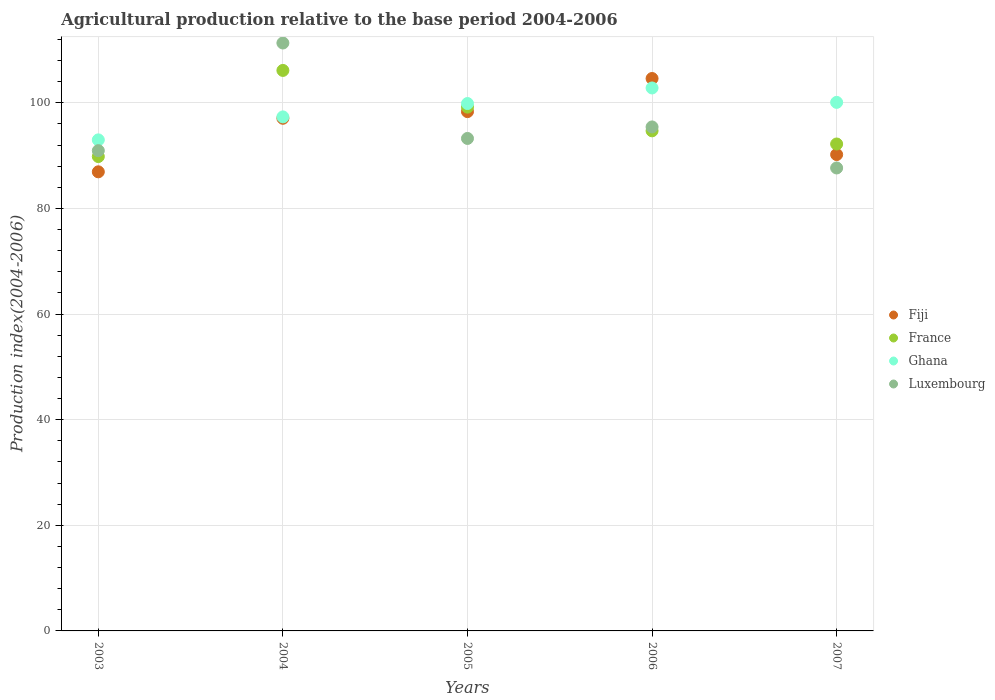How many different coloured dotlines are there?
Provide a succinct answer. 4. Is the number of dotlines equal to the number of legend labels?
Your answer should be very brief. Yes. What is the agricultural production index in Fiji in 2006?
Keep it short and to the point. 104.6. Across all years, what is the maximum agricultural production index in Ghana?
Provide a succinct answer. 102.81. Across all years, what is the minimum agricultural production index in France?
Your response must be concise. 89.82. In which year was the agricultural production index in Fiji maximum?
Ensure brevity in your answer.  2006. What is the total agricultural production index in Ghana in the graph?
Your response must be concise. 493.06. What is the difference between the agricultural production index in France in 2003 and that in 2006?
Ensure brevity in your answer.  -4.87. What is the difference between the agricultural production index in Fiji in 2006 and the agricultural production index in Luxembourg in 2007?
Your answer should be very brief. 16.94. What is the average agricultural production index in Ghana per year?
Make the answer very short. 98.61. In the year 2007, what is the difference between the agricultural production index in Luxembourg and agricultural production index in Ghana?
Make the answer very short. -12.42. What is the ratio of the agricultural production index in Ghana in 2003 to that in 2007?
Your response must be concise. 0.93. Is the agricultural production index in Luxembourg in 2003 less than that in 2005?
Provide a succinct answer. Yes. What is the difference between the highest and the second highest agricultural production index in Fiji?
Provide a succinct answer. 6.27. What is the difference between the highest and the lowest agricultural production index in Luxembourg?
Make the answer very short. 23.66. Is it the case that in every year, the sum of the agricultural production index in Luxembourg and agricultural production index in Ghana  is greater than the agricultural production index in France?
Offer a terse response. Yes. Is the agricultural production index in Luxembourg strictly less than the agricultural production index in Ghana over the years?
Your response must be concise. No. How many years are there in the graph?
Give a very brief answer. 5. What is the difference between two consecutive major ticks on the Y-axis?
Offer a very short reply. 20. Are the values on the major ticks of Y-axis written in scientific E-notation?
Provide a short and direct response. No. How many legend labels are there?
Your answer should be compact. 4. What is the title of the graph?
Make the answer very short. Agricultural production relative to the base period 2004-2006. What is the label or title of the X-axis?
Provide a succinct answer. Years. What is the label or title of the Y-axis?
Give a very brief answer. Production index(2004-2006). What is the Production index(2004-2006) of Fiji in 2003?
Provide a short and direct response. 86.93. What is the Production index(2004-2006) of France in 2003?
Keep it short and to the point. 89.82. What is the Production index(2004-2006) in Ghana in 2003?
Provide a short and direct response. 92.98. What is the Production index(2004-2006) in Luxembourg in 2003?
Ensure brevity in your answer.  90.94. What is the Production index(2004-2006) in Fiji in 2004?
Ensure brevity in your answer.  97.07. What is the Production index(2004-2006) of France in 2004?
Offer a terse response. 106.13. What is the Production index(2004-2006) in Ghana in 2004?
Your answer should be compact. 97.33. What is the Production index(2004-2006) of Luxembourg in 2004?
Give a very brief answer. 111.32. What is the Production index(2004-2006) of Fiji in 2005?
Provide a succinct answer. 98.33. What is the Production index(2004-2006) of France in 2005?
Ensure brevity in your answer.  99.18. What is the Production index(2004-2006) of Ghana in 2005?
Provide a succinct answer. 99.86. What is the Production index(2004-2006) of Luxembourg in 2005?
Your response must be concise. 93.25. What is the Production index(2004-2006) in Fiji in 2006?
Ensure brevity in your answer.  104.6. What is the Production index(2004-2006) of France in 2006?
Ensure brevity in your answer.  94.69. What is the Production index(2004-2006) in Ghana in 2006?
Offer a terse response. 102.81. What is the Production index(2004-2006) in Luxembourg in 2006?
Make the answer very short. 95.43. What is the Production index(2004-2006) in Fiji in 2007?
Your response must be concise. 90.2. What is the Production index(2004-2006) of France in 2007?
Provide a short and direct response. 92.2. What is the Production index(2004-2006) of Ghana in 2007?
Ensure brevity in your answer.  100.08. What is the Production index(2004-2006) of Luxembourg in 2007?
Provide a succinct answer. 87.66. Across all years, what is the maximum Production index(2004-2006) of Fiji?
Provide a short and direct response. 104.6. Across all years, what is the maximum Production index(2004-2006) in France?
Ensure brevity in your answer.  106.13. Across all years, what is the maximum Production index(2004-2006) in Ghana?
Keep it short and to the point. 102.81. Across all years, what is the maximum Production index(2004-2006) in Luxembourg?
Offer a terse response. 111.32. Across all years, what is the minimum Production index(2004-2006) of Fiji?
Offer a very short reply. 86.93. Across all years, what is the minimum Production index(2004-2006) of France?
Give a very brief answer. 89.82. Across all years, what is the minimum Production index(2004-2006) of Ghana?
Your response must be concise. 92.98. Across all years, what is the minimum Production index(2004-2006) of Luxembourg?
Offer a terse response. 87.66. What is the total Production index(2004-2006) of Fiji in the graph?
Give a very brief answer. 477.13. What is the total Production index(2004-2006) of France in the graph?
Keep it short and to the point. 482.02. What is the total Production index(2004-2006) in Ghana in the graph?
Ensure brevity in your answer.  493.06. What is the total Production index(2004-2006) of Luxembourg in the graph?
Your answer should be very brief. 478.6. What is the difference between the Production index(2004-2006) in Fiji in 2003 and that in 2004?
Ensure brevity in your answer.  -10.14. What is the difference between the Production index(2004-2006) in France in 2003 and that in 2004?
Make the answer very short. -16.31. What is the difference between the Production index(2004-2006) in Ghana in 2003 and that in 2004?
Offer a very short reply. -4.35. What is the difference between the Production index(2004-2006) in Luxembourg in 2003 and that in 2004?
Your response must be concise. -20.38. What is the difference between the Production index(2004-2006) in Fiji in 2003 and that in 2005?
Keep it short and to the point. -11.4. What is the difference between the Production index(2004-2006) in France in 2003 and that in 2005?
Keep it short and to the point. -9.36. What is the difference between the Production index(2004-2006) in Ghana in 2003 and that in 2005?
Your answer should be compact. -6.88. What is the difference between the Production index(2004-2006) in Luxembourg in 2003 and that in 2005?
Keep it short and to the point. -2.31. What is the difference between the Production index(2004-2006) of Fiji in 2003 and that in 2006?
Provide a succinct answer. -17.67. What is the difference between the Production index(2004-2006) in France in 2003 and that in 2006?
Your answer should be compact. -4.87. What is the difference between the Production index(2004-2006) in Ghana in 2003 and that in 2006?
Make the answer very short. -9.83. What is the difference between the Production index(2004-2006) in Luxembourg in 2003 and that in 2006?
Keep it short and to the point. -4.49. What is the difference between the Production index(2004-2006) of Fiji in 2003 and that in 2007?
Make the answer very short. -3.27. What is the difference between the Production index(2004-2006) of France in 2003 and that in 2007?
Make the answer very short. -2.38. What is the difference between the Production index(2004-2006) in Luxembourg in 2003 and that in 2007?
Provide a short and direct response. 3.28. What is the difference between the Production index(2004-2006) in Fiji in 2004 and that in 2005?
Provide a short and direct response. -1.26. What is the difference between the Production index(2004-2006) in France in 2004 and that in 2005?
Ensure brevity in your answer.  6.95. What is the difference between the Production index(2004-2006) of Ghana in 2004 and that in 2005?
Your response must be concise. -2.53. What is the difference between the Production index(2004-2006) in Luxembourg in 2004 and that in 2005?
Your response must be concise. 18.07. What is the difference between the Production index(2004-2006) in Fiji in 2004 and that in 2006?
Offer a very short reply. -7.53. What is the difference between the Production index(2004-2006) of France in 2004 and that in 2006?
Keep it short and to the point. 11.44. What is the difference between the Production index(2004-2006) of Ghana in 2004 and that in 2006?
Provide a short and direct response. -5.48. What is the difference between the Production index(2004-2006) in Luxembourg in 2004 and that in 2006?
Your answer should be compact. 15.89. What is the difference between the Production index(2004-2006) of Fiji in 2004 and that in 2007?
Offer a very short reply. 6.87. What is the difference between the Production index(2004-2006) in France in 2004 and that in 2007?
Keep it short and to the point. 13.93. What is the difference between the Production index(2004-2006) in Ghana in 2004 and that in 2007?
Provide a short and direct response. -2.75. What is the difference between the Production index(2004-2006) in Luxembourg in 2004 and that in 2007?
Offer a terse response. 23.66. What is the difference between the Production index(2004-2006) in Fiji in 2005 and that in 2006?
Ensure brevity in your answer.  -6.27. What is the difference between the Production index(2004-2006) in France in 2005 and that in 2006?
Make the answer very short. 4.49. What is the difference between the Production index(2004-2006) in Ghana in 2005 and that in 2006?
Provide a short and direct response. -2.95. What is the difference between the Production index(2004-2006) in Luxembourg in 2005 and that in 2006?
Provide a short and direct response. -2.18. What is the difference between the Production index(2004-2006) of Fiji in 2005 and that in 2007?
Make the answer very short. 8.13. What is the difference between the Production index(2004-2006) of France in 2005 and that in 2007?
Offer a terse response. 6.98. What is the difference between the Production index(2004-2006) in Ghana in 2005 and that in 2007?
Make the answer very short. -0.22. What is the difference between the Production index(2004-2006) in Luxembourg in 2005 and that in 2007?
Your answer should be very brief. 5.59. What is the difference between the Production index(2004-2006) in Fiji in 2006 and that in 2007?
Make the answer very short. 14.4. What is the difference between the Production index(2004-2006) of France in 2006 and that in 2007?
Make the answer very short. 2.49. What is the difference between the Production index(2004-2006) in Ghana in 2006 and that in 2007?
Provide a short and direct response. 2.73. What is the difference between the Production index(2004-2006) of Luxembourg in 2006 and that in 2007?
Ensure brevity in your answer.  7.77. What is the difference between the Production index(2004-2006) in Fiji in 2003 and the Production index(2004-2006) in France in 2004?
Offer a very short reply. -19.2. What is the difference between the Production index(2004-2006) in Fiji in 2003 and the Production index(2004-2006) in Luxembourg in 2004?
Provide a succinct answer. -24.39. What is the difference between the Production index(2004-2006) of France in 2003 and the Production index(2004-2006) of Ghana in 2004?
Ensure brevity in your answer.  -7.51. What is the difference between the Production index(2004-2006) of France in 2003 and the Production index(2004-2006) of Luxembourg in 2004?
Keep it short and to the point. -21.5. What is the difference between the Production index(2004-2006) of Ghana in 2003 and the Production index(2004-2006) of Luxembourg in 2004?
Offer a terse response. -18.34. What is the difference between the Production index(2004-2006) of Fiji in 2003 and the Production index(2004-2006) of France in 2005?
Offer a terse response. -12.25. What is the difference between the Production index(2004-2006) of Fiji in 2003 and the Production index(2004-2006) of Ghana in 2005?
Ensure brevity in your answer.  -12.93. What is the difference between the Production index(2004-2006) of Fiji in 2003 and the Production index(2004-2006) of Luxembourg in 2005?
Offer a terse response. -6.32. What is the difference between the Production index(2004-2006) in France in 2003 and the Production index(2004-2006) in Ghana in 2005?
Offer a very short reply. -10.04. What is the difference between the Production index(2004-2006) of France in 2003 and the Production index(2004-2006) of Luxembourg in 2005?
Provide a succinct answer. -3.43. What is the difference between the Production index(2004-2006) of Ghana in 2003 and the Production index(2004-2006) of Luxembourg in 2005?
Your response must be concise. -0.27. What is the difference between the Production index(2004-2006) of Fiji in 2003 and the Production index(2004-2006) of France in 2006?
Your answer should be compact. -7.76. What is the difference between the Production index(2004-2006) of Fiji in 2003 and the Production index(2004-2006) of Ghana in 2006?
Offer a very short reply. -15.88. What is the difference between the Production index(2004-2006) in Fiji in 2003 and the Production index(2004-2006) in Luxembourg in 2006?
Offer a very short reply. -8.5. What is the difference between the Production index(2004-2006) in France in 2003 and the Production index(2004-2006) in Ghana in 2006?
Offer a very short reply. -12.99. What is the difference between the Production index(2004-2006) in France in 2003 and the Production index(2004-2006) in Luxembourg in 2006?
Keep it short and to the point. -5.61. What is the difference between the Production index(2004-2006) of Ghana in 2003 and the Production index(2004-2006) of Luxembourg in 2006?
Your answer should be compact. -2.45. What is the difference between the Production index(2004-2006) in Fiji in 2003 and the Production index(2004-2006) in France in 2007?
Ensure brevity in your answer.  -5.27. What is the difference between the Production index(2004-2006) of Fiji in 2003 and the Production index(2004-2006) of Ghana in 2007?
Make the answer very short. -13.15. What is the difference between the Production index(2004-2006) in Fiji in 2003 and the Production index(2004-2006) in Luxembourg in 2007?
Keep it short and to the point. -0.73. What is the difference between the Production index(2004-2006) of France in 2003 and the Production index(2004-2006) of Ghana in 2007?
Your answer should be compact. -10.26. What is the difference between the Production index(2004-2006) in France in 2003 and the Production index(2004-2006) in Luxembourg in 2007?
Provide a short and direct response. 2.16. What is the difference between the Production index(2004-2006) in Ghana in 2003 and the Production index(2004-2006) in Luxembourg in 2007?
Your response must be concise. 5.32. What is the difference between the Production index(2004-2006) in Fiji in 2004 and the Production index(2004-2006) in France in 2005?
Keep it short and to the point. -2.11. What is the difference between the Production index(2004-2006) of Fiji in 2004 and the Production index(2004-2006) of Ghana in 2005?
Give a very brief answer. -2.79. What is the difference between the Production index(2004-2006) of Fiji in 2004 and the Production index(2004-2006) of Luxembourg in 2005?
Make the answer very short. 3.82. What is the difference between the Production index(2004-2006) of France in 2004 and the Production index(2004-2006) of Ghana in 2005?
Give a very brief answer. 6.27. What is the difference between the Production index(2004-2006) in France in 2004 and the Production index(2004-2006) in Luxembourg in 2005?
Your answer should be very brief. 12.88. What is the difference between the Production index(2004-2006) in Ghana in 2004 and the Production index(2004-2006) in Luxembourg in 2005?
Your response must be concise. 4.08. What is the difference between the Production index(2004-2006) in Fiji in 2004 and the Production index(2004-2006) in France in 2006?
Offer a terse response. 2.38. What is the difference between the Production index(2004-2006) in Fiji in 2004 and the Production index(2004-2006) in Ghana in 2006?
Ensure brevity in your answer.  -5.74. What is the difference between the Production index(2004-2006) in Fiji in 2004 and the Production index(2004-2006) in Luxembourg in 2006?
Your answer should be compact. 1.64. What is the difference between the Production index(2004-2006) in France in 2004 and the Production index(2004-2006) in Ghana in 2006?
Give a very brief answer. 3.32. What is the difference between the Production index(2004-2006) in Ghana in 2004 and the Production index(2004-2006) in Luxembourg in 2006?
Your answer should be very brief. 1.9. What is the difference between the Production index(2004-2006) in Fiji in 2004 and the Production index(2004-2006) in France in 2007?
Your answer should be compact. 4.87. What is the difference between the Production index(2004-2006) of Fiji in 2004 and the Production index(2004-2006) of Ghana in 2007?
Your answer should be compact. -3.01. What is the difference between the Production index(2004-2006) in Fiji in 2004 and the Production index(2004-2006) in Luxembourg in 2007?
Offer a terse response. 9.41. What is the difference between the Production index(2004-2006) in France in 2004 and the Production index(2004-2006) in Ghana in 2007?
Provide a succinct answer. 6.05. What is the difference between the Production index(2004-2006) of France in 2004 and the Production index(2004-2006) of Luxembourg in 2007?
Keep it short and to the point. 18.47. What is the difference between the Production index(2004-2006) in Ghana in 2004 and the Production index(2004-2006) in Luxembourg in 2007?
Your answer should be very brief. 9.67. What is the difference between the Production index(2004-2006) of Fiji in 2005 and the Production index(2004-2006) of France in 2006?
Offer a very short reply. 3.64. What is the difference between the Production index(2004-2006) in Fiji in 2005 and the Production index(2004-2006) in Ghana in 2006?
Provide a short and direct response. -4.48. What is the difference between the Production index(2004-2006) in Fiji in 2005 and the Production index(2004-2006) in Luxembourg in 2006?
Offer a very short reply. 2.9. What is the difference between the Production index(2004-2006) in France in 2005 and the Production index(2004-2006) in Ghana in 2006?
Your answer should be compact. -3.63. What is the difference between the Production index(2004-2006) in France in 2005 and the Production index(2004-2006) in Luxembourg in 2006?
Your answer should be very brief. 3.75. What is the difference between the Production index(2004-2006) of Ghana in 2005 and the Production index(2004-2006) of Luxembourg in 2006?
Ensure brevity in your answer.  4.43. What is the difference between the Production index(2004-2006) of Fiji in 2005 and the Production index(2004-2006) of France in 2007?
Provide a succinct answer. 6.13. What is the difference between the Production index(2004-2006) of Fiji in 2005 and the Production index(2004-2006) of Ghana in 2007?
Provide a short and direct response. -1.75. What is the difference between the Production index(2004-2006) of Fiji in 2005 and the Production index(2004-2006) of Luxembourg in 2007?
Your answer should be very brief. 10.67. What is the difference between the Production index(2004-2006) in France in 2005 and the Production index(2004-2006) in Ghana in 2007?
Make the answer very short. -0.9. What is the difference between the Production index(2004-2006) of France in 2005 and the Production index(2004-2006) of Luxembourg in 2007?
Provide a succinct answer. 11.52. What is the difference between the Production index(2004-2006) of Ghana in 2005 and the Production index(2004-2006) of Luxembourg in 2007?
Offer a very short reply. 12.2. What is the difference between the Production index(2004-2006) in Fiji in 2006 and the Production index(2004-2006) in France in 2007?
Provide a succinct answer. 12.4. What is the difference between the Production index(2004-2006) of Fiji in 2006 and the Production index(2004-2006) of Ghana in 2007?
Keep it short and to the point. 4.52. What is the difference between the Production index(2004-2006) in Fiji in 2006 and the Production index(2004-2006) in Luxembourg in 2007?
Offer a very short reply. 16.94. What is the difference between the Production index(2004-2006) in France in 2006 and the Production index(2004-2006) in Ghana in 2007?
Your response must be concise. -5.39. What is the difference between the Production index(2004-2006) of France in 2006 and the Production index(2004-2006) of Luxembourg in 2007?
Provide a short and direct response. 7.03. What is the difference between the Production index(2004-2006) in Ghana in 2006 and the Production index(2004-2006) in Luxembourg in 2007?
Provide a succinct answer. 15.15. What is the average Production index(2004-2006) in Fiji per year?
Your answer should be very brief. 95.43. What is the average Production index(2004-2006) in France per year?
Provide a short and direct response. 96.4. What is the average Production index(2004-2006) of Ghana per year?
Offer a terse response. 98.61. What is the average Production index(2004-2006) of Luxembourg per year?
Your response must be concise. 95.72. In the year 2003, what is the difference between the Production index(2004-2006) in Fiji and Production index(2004-2006) in France?
Make the answer very short. -2.89. In the year 2003, what is the difference between the Production index(2004-2006) in Fiji and Production index(2004-2006) in Ghana?
Make the answer very short. -6.05. In the year 2003, what is the difference between the Production index(2004-2006) of Fiji and Production index(2004-2006) of Luxembourg?
Offer a very short reply. -4.01. In the year 2003, what is the difference between the Production index(2004-2006) in France and Production index(2004-2006) in Ghana?
Offer a terse response. -3.16. In the year 2003, what is the difference between the Production index(2004-2006) in France and Production index(2004-2006) in Luxembourg?
Ensure brevity in your answer.  -1.12. In the year 2003, what is the difference between the Production index(2004-2006) of Ghana and Production index(2004-2006) of Luxembourg?
Your response must be concise. 2.04. In the year 2004, what is the difference between the Production index(2004-2006) in Fiji and Production index(2004-2006) in France?
Give a very brief answer. -9.06. In the year 2004, what is the difference between the Production index(2004-2006) of Fiji and Production index(2004-2006) of Ghana?
Your answer should be compact. -0.26. In the year 2004, what is the difference between the Production index(2004-2006) in Fiji and Production index(2004-2006) in Luxembourg?
Ensure brevity in your answer.  -14.25. In the year 2004, what is the difference between the Production index(2004-2006) of France and Production index(2004-2006) of Ghana?
Your response must be concise. 8.8. In the year 2004, what is the difference between the Production index(2004-2006) of France and Production index(2004-2006) of Luxembourg?
Your answer should be very brief. -5.19. In the year 2004, what is the difference between the Production index(2004-2006) in Ghana and Production index(2004-2006) in Luxembourg?
Offer a terse response. -13.99. In the year 2005, what is the difference between the Production index(2004-2006) in Fiji and Production index(2004-2006) in France?
Your answer should be very brief. -0.85. In the year 2005, what is the difference between the Production index(2004-2006) in Fiji and Production index(2004-2006) in Ghana?
Keep it short and to the point. -1.53. In the year 2005, what is the difference between the Production index(2004-2006) of Fiji and Production index(2004-2006) of Luxembourg?
Make the answer very short. 5.08. In the year 2005, what is the difference between the Production index(2004-2006) in France and Production index(2004-2006) in Ghana?
Provide a short and direct response. -0.68. In the year 2005, what is the difference between the Production index(2004-2006) of France and Production index(2004-2006) of Luxembourg?
Offer a very short reply. 5.93. In the year 2005, what is the difference between the Production index(2004-2006) of Ghana and Production index(2004-2006) of Luxembourg?
Your answer should be compact. 6.61. In the year 2006, what is the difference between the Production index(2004-2006) in Fiji and Production index(2004-2006) in France?
Keep it short and to the point. 9.91. In the year 2006, what is the difference between the Production index(2004-2006) in Fiji and Production index(2004-2006) in Ghana?
Ensure brevity in your answer.  1.79. In the year 2006, what is the difference between the Production index(2004-2006) of Fiji and Production index(2004-2006) of Luxembourg?
Your answer should be compact. 9.17. In the year 2006, what is the difference between the Production index(2004-2006) of France and Production index(2004-2006) of Ghana?
Provide a short and direct response. -8.12. In the year 2006, what is the difference between the Production index(2004-2006) in France and Production index(2004-2006) in Luxembourg?
Provide a short and direct response. -0.74. In the year 2006, what is the difference between the Production index(2004-2006) in Ghana and Production index(2004-2006) in Luxembourg?
Provide a succinct answer. 7.38. In the year 2007, what is the difference between the Production index(2004-2006) in Fiji and Production index(2004-2006) in Ghana?
Ensure brevity in your answer.  -9.88. In the year 2007, what is the difference between the Production index(2004-2006) in Fiji and Production index(2004-2006) in Luxembourg?
Your answer should be compact. 2.54. In the year 2007, what is the difference between the Production index(2004-2006) in France and Production index(2004-2006) in Ghana?
Ensure brevity in your answer.  -7.88. In the year 2007, what is the difference between the Production index(2004-2006) in France and Production index(2004-2006) in Luxembourg?
Offer a very short reply. 4.54. In the year 2007, what is the difference between the Production index(2004-2006) in Ghana and Production index(2004-2006) in Luxembourg?
Provide a succinct answer. 12.42. What is the ratio of the Production index(2004-2006) in Fiji in 2003 to that in 2004?
Offer a very short reply. 0.9. What is the ratio of the Production index(2004-2006) of France in 2003 to that in 2004?
Provide a succinct answer. 0.85. What is the ratio of the Production index(2004-2006) of Ghana in 2003 to that in 2004?
Your answer should be very brief. 0.96. What is the ratio of the Production index(2004-2006) in Luxembourg in 2003 to that in 2004?
Offer a terse response. 0.82. What is the ratio of the Production index(2004-2006) in Fiji in 2003 to that in 2005?
Offer a terse response. 0.88. What is the ratio of the Production index(2004-2006) of France in 2003 to that in 2005?
Give a very brief answer. 0.91. What is the ratio of the Production index(2004-2006) of Ghana in 2003 to that in 2005?
Offer a very short reply. 0.93. What is the ratio of the Production index(2004-2006) in Luxembourg in 2003 to that in 2005?
Provide a short and direct response. 0.98. What is the ratio of the Production index(2004-2006) in Fiji in 2003 to that in 2006?
Offer a very short reply. 0.83. What is the ratio of the Production index(2004-2006) in France in 2003 to that in 2006?
Make the answer very short. 0.95. What is the ratio of the Production index(2004-2006) in Ghana in 2003 to that in 2006?
Your answer should be compact. 0.9. What is the ratio of the Production index(2004-2006) of Luxembourg in 2003 to that in 2006?
Ensure brevity in your answer.  0.95. What is the ratio of the Production index(2004-2006) in Fiji in 2003 to that in 2007?
Keep it short and to the point. 0.96. What is the ratio of the Production index(2004-2006) of France in 2003 to that in 2007?
Your answer should be very brief. 0.97. What is the ratio of the Production index(2004-2006) of Ghana in 2003 to that in 2007?
Give a very brief answer. 0.93. What is the ratio of the Production index(2004-2006) of Luxembourg in 2003 to that in 2007?
Your answer should be very brief. 1.04. What is the ratio of the Production index(2004-2006) in Fiji in 2004 to that in 2005?
Keep it short and to the point. 0.99. What is the ratio of the Production index(2004-2006) in France in 2004 to that in 2005?
Give a very brief answer. 1.07. What is the ratio of the Production index(2004-2006) in Ghana in 2004 to that in 2005?
Make the answer very short. 0.97. What is the ratio of the Production index(2004-2006) of Luxembourg in 2004 to that in 2005?
Provide a short and direct response. 1.19. What is the ratio of the Production index(2004-2006) of Fiji in 2004 to that in 2006?
Make the answer very short. 0.93. What is the ratio of the Production index(2004-2006) of France in 2004 to that in 2006?
Make the answer very short. 1.12. What is the ratio of the Production index(2004-2006) of Ghana in 2004 to that in 2006?
Your response must be concise. 0.95. What is the ratio of the Production index(2004-2006) of Luxembourg in 2004 to that in 2006?
Provide a succinct answer. 1.17. What is the ratio of the Production index(2004-2006) in Fiji in 2004 to that in 2007?
Make the answer very short. 1.08. What is the ratio of the Production index(2004-2006) of France in 2004 to that in 2007?
Your response must be concise. 1.15. What is the ratio of the Production index(2004-2006) in Ghana in 2004 to that in 2007?
Your answer should be compact. 0.97. What is the ratio of the Production index(2004-2006) in Luxembourg in 2004 to that in 2007?
Your answer should be compact. 1.27. What is the ratio of the Production index(2004-2006) of Fiji in 2005 to that in 2006?
Your answer should be compact. 0.94. What is the ratio of the Production index(2004-2006) of France in 2005 to that in 2006?
Your answer should be compact. 1.05. What is the ratio of the Production index(2004-2006) of Ghana in 2005 to that in 2006?
Keep it short and to the point. 0.97. What is the ratio of the Production index(2004-2006) in Luxembourg in 2005 to that in 2006?
Offer a very short reply. 0.98. What is the ratio of the Production index(2004-2006) in Fiji in 2005 to that in 2007?
Ensure brevity in your answer.  1.09. What is the ratio of the Production index(2004-2006) in France in 2005 to that in 2007?
Ensure brevity in your answer.  1.08. What is the ratio of the Production index(2004-2006) of Ghana in 2005 to that in 2007?
Provide a short and direct response. 1. What is the ratio of the Production index(2004-2006) of Luxembourg in 2005 to that in 2007?
Offer a terse response. 1.06. What is the ratio of the Production index(2004-2006) in Fiji in 2006 to that in 2007?
Offer a very short reply. 1.16. What is the ratio of the Production index(2004-2006) in France in 2006 to that in 2007?
Offer a very short reply. 1.03. What is the ratio of the Production index(2004-2006) in Ghana in 2006 to that in 2007?
Make the answer very short. 1.03. What is the ratio of the Production index(2004-2006) of Luxembourg in 2006 to that in 2007?
Provide a succinct answer. 1.09. What is the difference between the highest and the second highest Production index(2004-2006) in Fiji?
Make the answer very short. 6.27. What is the difference between the highest and the second highest Production index(2004-2006) in France?
Provide a short and direct response. 6.95. What is the difference between the highest and the second highest Production index(2004-2006) of Ghana?
Keep it short and to the point. 2.73. What is the difference between the highest and the second highest Production index(2004-2006) in Luxembourg?
Your answer should be very brief. 15.89. What is the difference between the highest and the lowest Production index(2004-2006) in Fiji?
Your response must be concise. 17.67. What is the difference between the highest and the lowest Production index(2004-2006) in France?
Keep it short and to the point. 16.31. What is the difference between the highest and the lowest Production index(2004-2006) of Ghana?
Provide a short and direct response. 9.83. What is the difference between the highest and the lowest Production index(2004-2006) of Luxembourg?
Provide a succinct answer. 23.66. 